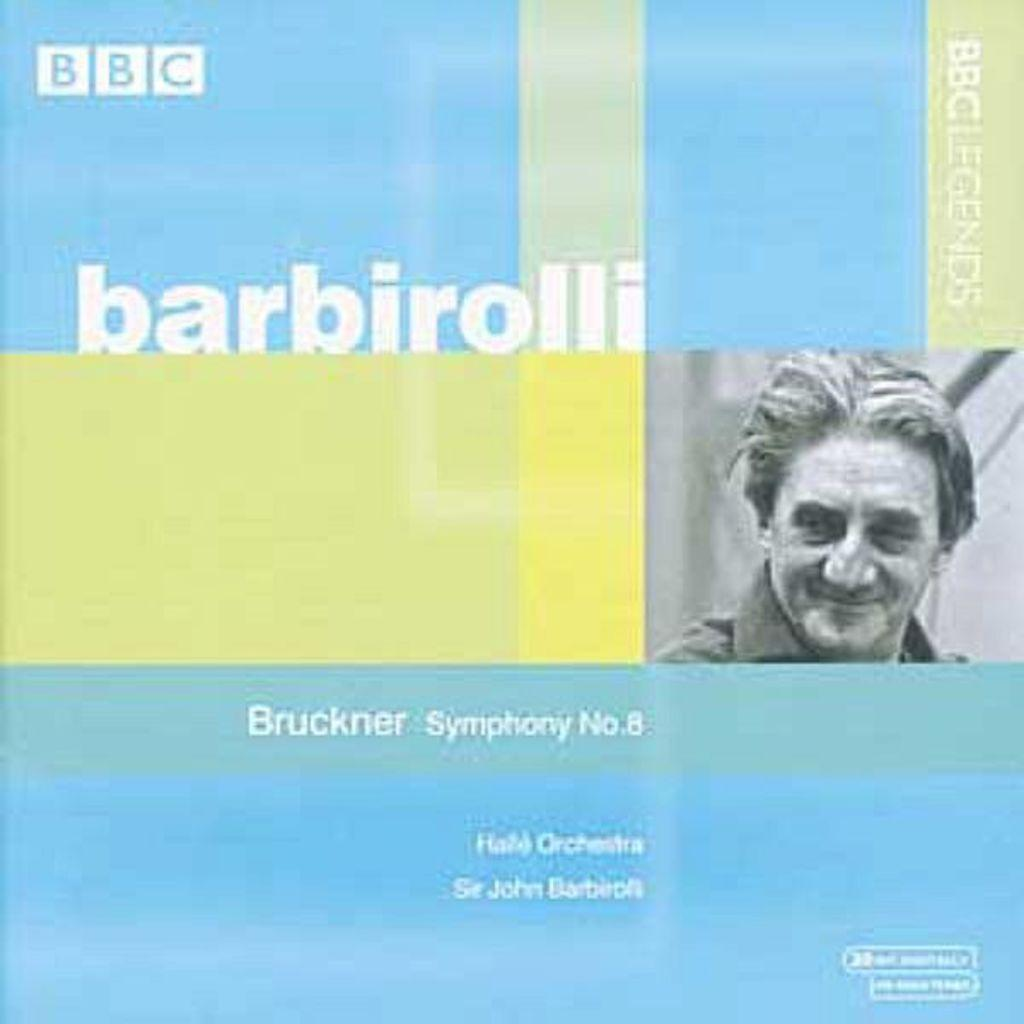What type of visual is the image? The image is a poster. What is depicted on the poster? There is a photo of a person on the poster. Are there any numerical elements on the poster? Yes, there are numbers on the poster. What other textual elements are present on the poster? There are words on the poster. What type of lettuce is being used as a prop in the photo on the poster? There is no lettuce present in the photo on the poster. How does the person in the photo on the poster plan to break the record? The image does not provide information about any records or attempts to break them. 